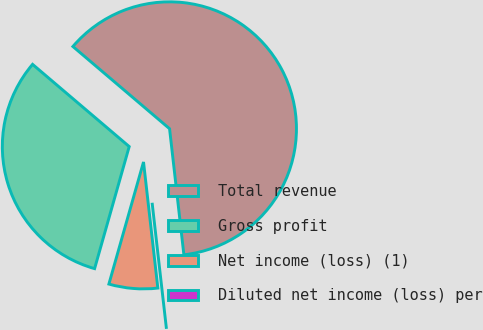<chart> <loc_0><loc_0><loc_500><loc_500><pie_chart><fcel>Total revenue<fcel>Gross profit<fcel>Net income (loss) (1)<fcel>Diluted net income (loss) per<nl><fcel>61.98%<fcel>31.82%<fcel>6.2%<fcel>0.0%<nl></chart> 